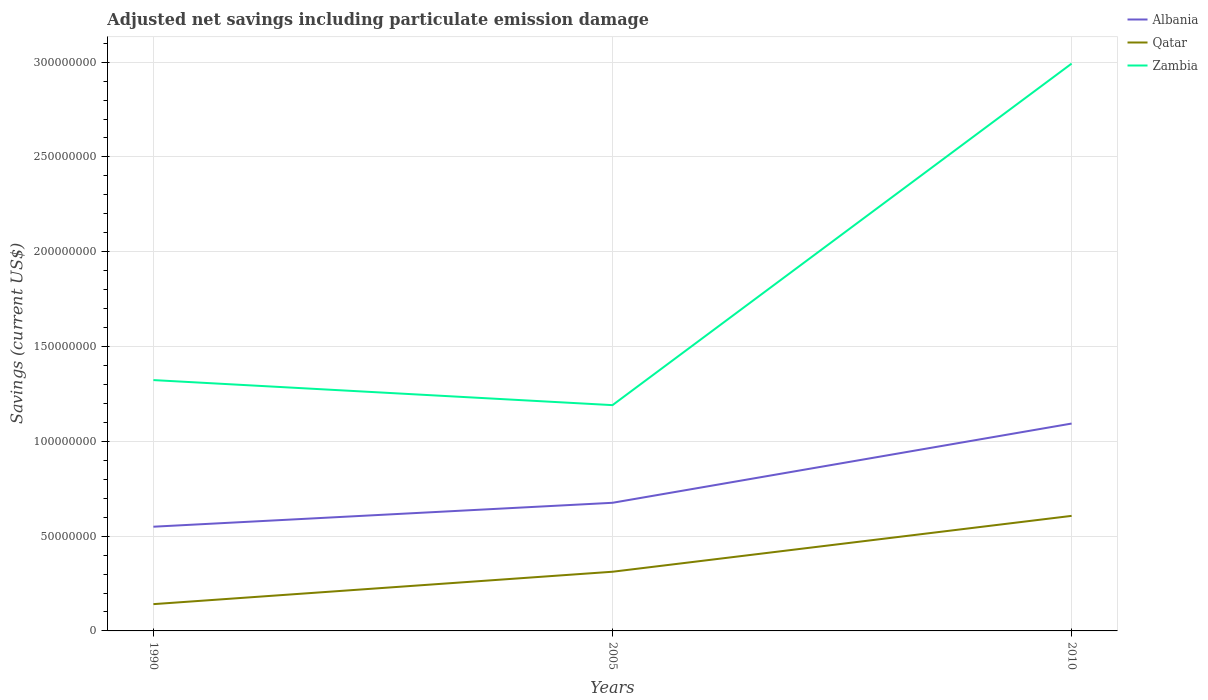How many different coloured lines are there?
Offer a very short reply. 3. Across all years, what is the maximum net savings in Qatar?
Your answer should be compact. 1.41e+07. What is the total net savings in Zambia in the graph?
Make the answer very short. 1.32e+07. What is the difference between the highest and the second highest net savings in Albania?
Ensure brevity in your answer.  5.44e+07. How many years are there in the graph?
Keep it short and to the point. 3. What is the difference between two consecutive major ticks on the Y-axis?
Make the answer very short. 5.00e+07. Are the values on the major ticks of Y-axis written in scientific E-notation?
Ensure brevity in your answer.  No. Where does the legend appear in the graph?
Make the answer very short. Top right. How many legend labels are there?
Offer a very short reply. 3. How are the legend labels stacked?
Keep it short and to the point. Vertical. What is the title of the graph?
Keep it short and to the point. Adjusted net savings including particulate emission damage. What is the label or title of the Y-axis?
Give a very brief answer. Savings (current US$). What is the Savings (current US$) of Albania in 1990?
Offer a terse response. 5.50e+07. What is the Savings (current US$) of Qatar in 1990?
Make the answer very short. 1.41e+07. What is the Savings (current US$) of Zambia in 1990?
Give a very brief answer. 1.32e+08. What is the Savings (current US$) in Albania in 2005?
Make the answer very short. 6.76e+07. What is the Savings (current US$) of Qatar in 2005?
Your response must be concise. 3.12e+07. What is the Savings (current US$) in Zambia in 2005?
Provide a succinct answer. 1.19e+08. What is the Savings (current US$) of Albania in 2010?
Your response must be concise. 1.09e+08. What is the Savings (current US$) of Qatar in 2010?
Your answer should be very brief. 6.07e+07. What is the Savings (current US$) of Zambia in 2010?
Provide a succinct answer. 2.99e+08. Across all years, what is the maximum Savings (current US$) in Albania?
Give a very brief answer. 1.09e+08. Across all years, what is the maximum Savings (current US$) of Qatar?
Keep it short and to the point. 6.07e+07. Across all years, what is the maximum Savings (current US$) of Zambia?
Your answer should be very brief. 2.99e+08. Across all years, what is the minimum Savings (current US$) in Albania?
Your answer should be compact. 5.50e+07. Across all years, what is the minimum Savings (current US$) in Qatar?
Give a very brief answer. 1.41e+07. Across all years, what is the minimum Savings (current US$) in Zambia?
Your answer should be very brief. 1.19e+08. What is the total Savings (current US$) of Albania in the graph?
Provide a succinct answer. 2.32e+08. What is the total Savings (current US$) of Qatar in the graph?
Keep it short and to the point. 1.06e+08. What is the total Savings (current US$) of Zambia in the graph?
Keep it short and to the point. 5.51e+08. What is the difference between the Savings (current US$) of Albania in 1990 and that in 2005?
Offer a very short reply. -1.26e+07. What is the difference between the Savings (current US$) in Qatar in 1990 and that in 2005?
Your answer should be very brief. -1.71e+07. What is the difference between the Savings (current US$) in Zambia in 1990 and that in 2005?
Your answer should be compact. 1.32e+07. What is the difference between the Savings (current US$) in Albania in 1990 and that in 2010?
Make the answer very short. -5.44e+07. What is the difference between the Savings (current US$) of Qatar in 1990 and that in 2010?
Keep it short and to the point. -4.66e+07. What is the difference between the Savings (current US$) of Zambia in 1990 and that in 2010?
Provide a short and direct response. -1.67e+08. What is the difference between the Savings (current US$) of Albania in 2005 and that in 2010?
Keep it short and to the point. -4.18e+07. What is the difference between the Savings (current US$) in Qatar in 2005 and that in 2010?
Offer a very short reply. -2.95e+07. What is the difference between the Savings (current US$) of Zambia in 2005 and that in 2010?
Offer a terse response. -1.80e+08. What is the difference between the Savings (current US$) in Albania in 1990 and the Savings (current US$) in Qatar in 2005?
Your answer should be very brief. 2.38e+07. What is the difference between the Savings (current US$) of Albania in 1990 and the Savings (current US$) of Zambia in 2005?
Keep it short and to the point. -6.41e+07. What is the difference between the Savings (current US$) of Qatar in 1990 and the Savings (current US$) of Zambia in 2005?
Offer a terse response. -1.05e+08. What is the difference between the Savings (current US$) of Albania in 1990 and the Savings (current US$) of Qatar in 2010?
Ensure brevity in your answer.  -5.72e+06. What is the difference between the Savings (current US$) of Albania in 1990 and the Savings (current US$) of Zambia in 2010?
Offer a terse response. -2.44e+08. What is the difference between the Savings (current US$) in Qatar in 1990 and the Savings (current US$) in Zambia in 2010?
Your answer should be compact. -2.85e+08. What is the difference between the Savings (current US$) in Albania in 2005 and the Savings (current US$) in Qatar in 2010?
Your response must be concise. 6.90e+06. What is the difference between the Savings (current US$) in Albania in 2005 and the Savings (current US$) in Zambia in 2010?
Your response must be concise. -2.32e+08. What is the difference between the Savings (current US$) of Qatar in 2005 and the Savings (current US$) of Zambia in 2010?
Ensure brevity in your answer.  -2.68e+08. What is the average Savings (current US$) in Albania per year?
Your response must be concise. 7.73e+07. What is the average Savings (current US$) in Qatar per year?
Your answer should be compact. 3.53e+07. What is the average Savings (current US$) of Zambia per year?
Make the answer very short. 1.84e+08. In the year 1990, what is the difference between the Savings (current US$) in Albania and Savings (current US$) in Qatar?
Offer a terse response. 4.08e+07. In the year 1990, what is the difference between the Savings (current US$) of Albania and Savings (current US$) of Zambia?
Keep it short and to the point. -7.73e+07. In the year 1990, what is the difference between the Savings (current US$) of Qatar and Savings (current US$) of Zambia?
Your answer should be very brief. -1.18e+08. In the year 2005, what is the difference between the Savings (current US$) in Albania and Savings (current US$) in Qatar?
Make the answer very short. 3.64e+07. In the year 2005, what is the difference between the Savings (current US$) of Albania and Savings (current US$) of Zambia?
Offer a terse response. -5.15e+07. In the year 2005, what is the difference between the Savings (current US$) of Qatar and Savings (current US$) of Zambia?
Provide a succinct answer. -8.79e+07. In the year 2010, what is the difference between the Savings (current US$) of Albania and Savings (current US$) of Qatar?
Give a very brief answer. 4.87e+07. In the year 2010, what is the difference between the Savings (current US$) of Albania and Savings (current US$) of Zambia?
Ensure brevity in your answer.  -1.90e+08. In the year 2010, what is the difference between the Savings (current US$) of Qatar and Savings (current US$) of Zambia?
Your answer should be compact. -2.39e+08. What is the ratio of the Savings (current US$) in Albania in 1990 to that in 2005?
Give a very brief answer. 0.81. What is the ratio of the Savings (current US$) in Qatar in 1990 to that in 2005?
Provide a short and direct response. 0.45. What is the ratio of the Savings (current US$) in Zambia in 1990 to that in 2005?
Your answer should be very brief. 1.11. What is the ratio of the Savings (current US$) in Albania in 1990 to that in 2010?
Ensure brevity in your answer.  0.5. What is the ratio of the Savings (current US$) in Qatar in 1990 to that in 2010?
Your answer should be compact. 0.23. What is the ratio of the Savings (current US$) of Zambia in 1990 to that in 2010?
Offer a very short reply. 0.44. What is the ratio of the Savings (current US$) of Albania in 2005 to that in 2010?
Make the answer very short. 0.62. What is the ratio of the Savings (current US$) of Qatar in 2005 to that in 2010?
Provide a short and direct response. 0.51. What is the ratio of the Savings (current US$) in Zambia in 2005 to that in 2010?
Make the answer very short. 0.4. What is the difference between the highest and the second highest Savings (current US$) in Albania?
Your response must be concise. 4.18e+07. What is the difference between the highest and the second highest Savings (current US$) in Qatar?
Provide a succinct answer. 2.95e+07. What is the difference between the highest and the second highest Savings (current US$) of Zambia?
Your answer should be very brief. 1.67e+08. What is the difference between the highest and the lowest Savings (current US$) in Albania?
Make the answer very short. 5.44e+07. What is the difference between the highest and the lowest Savings (current US$) in Qatar?
Provide a succinct answer. 4.66e+07. What is the difference between the highest and the lowest Savings (current US$) of Zambia?
Offer a terse response. 1.80e+08. 